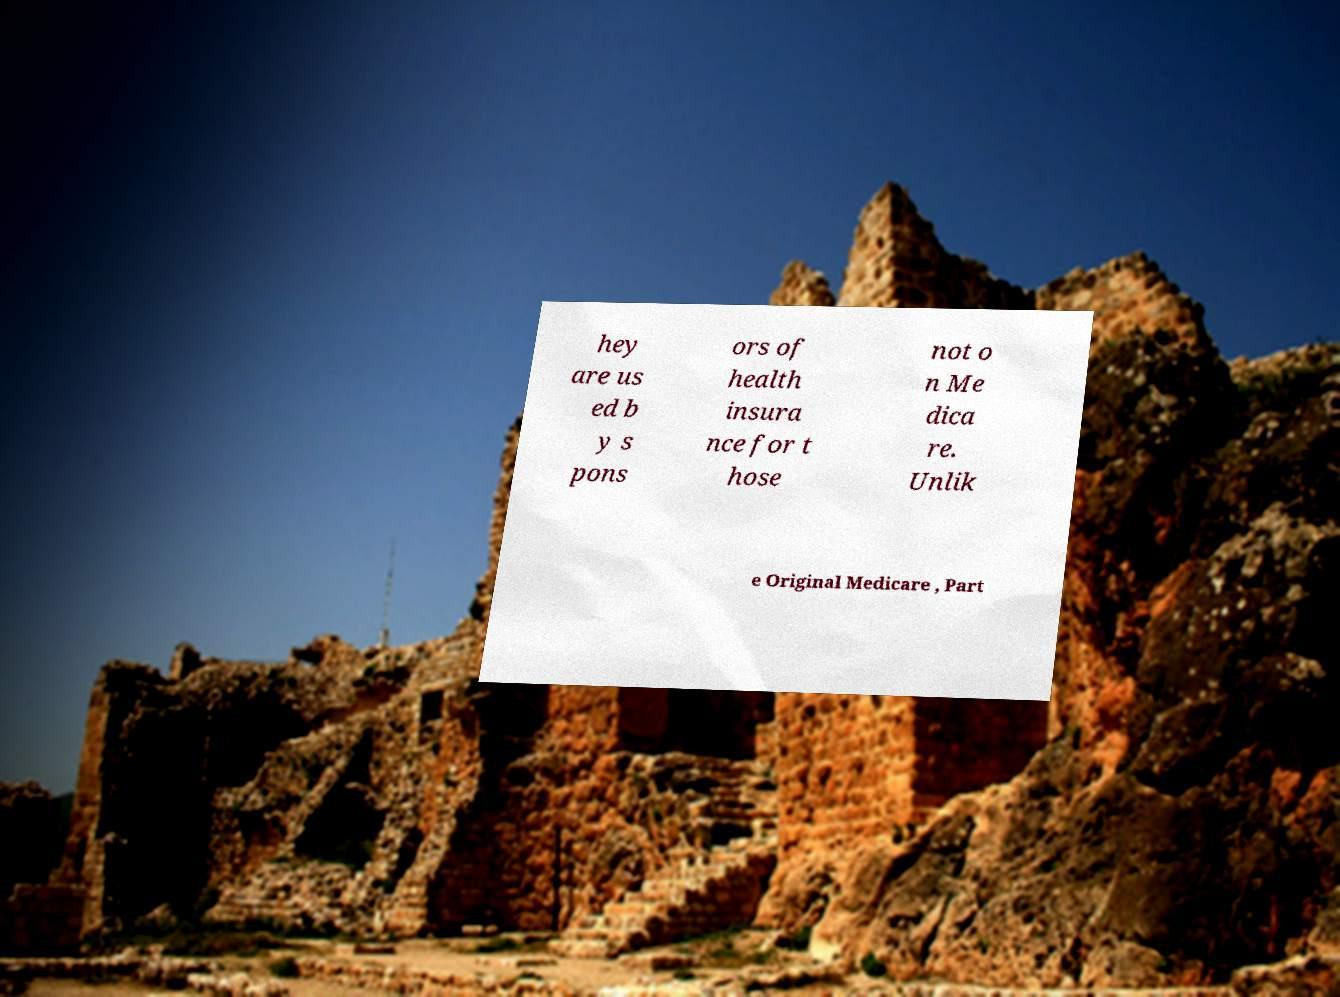What messages or text are displayed in this image? I need them in a readable, typed format. hey are us ed b y s pons ors of health insura nce for t hose not o n Me dica re. Unlik e Original Medicare , Part 